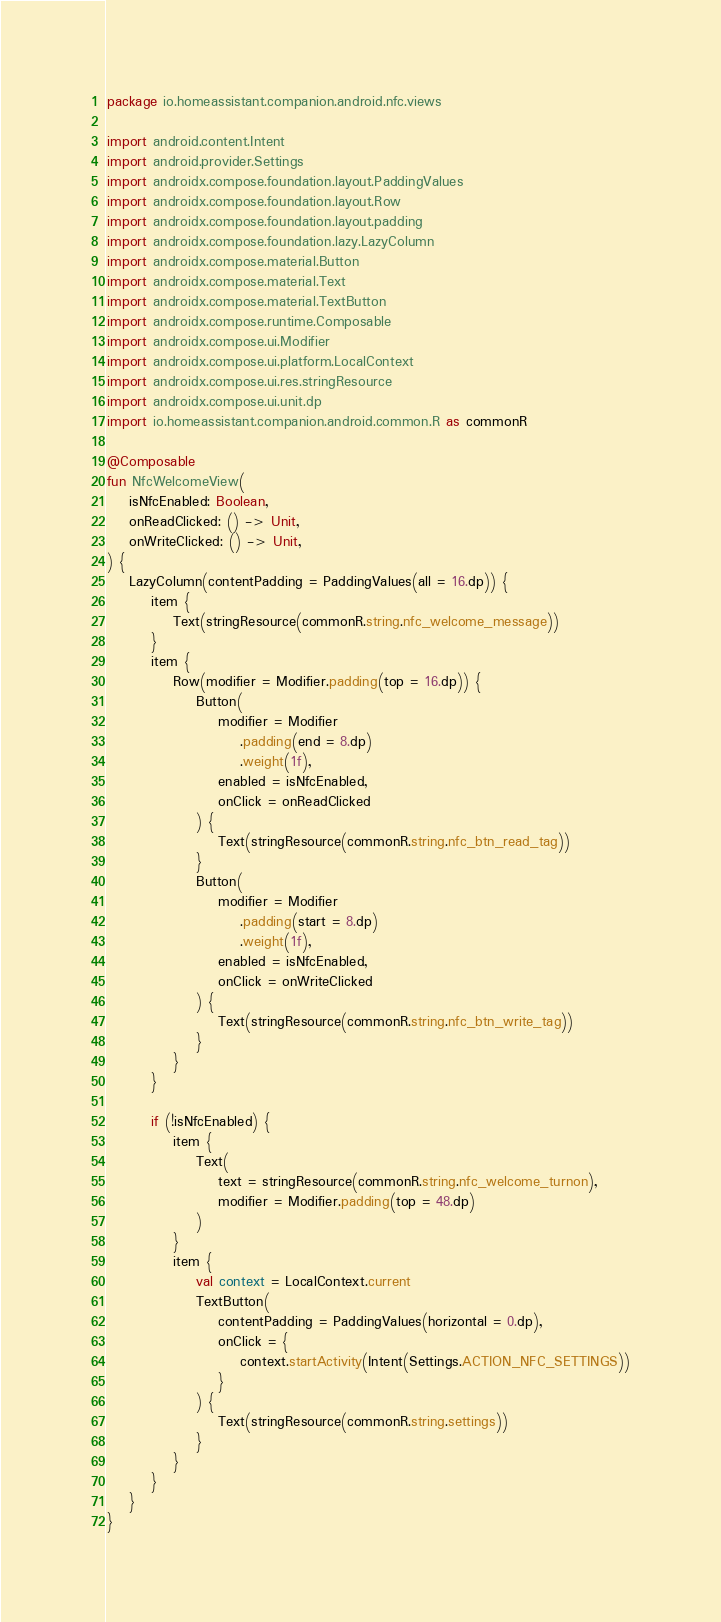Convert code to text. <code><loc_0><loc_0><loc_500><loc_500><_Kotlin_>package io.homeassistant.companion.android.nfc.views

import android.content.Intent
import android.provider.Settings
import androidx.compose.foundation.layout.PaddingValues
import androidx.compose.foundation.layout.Row
import androidx.compose.foundation.layout.padding
import androidx.compose.foundation.lazy.LazyColumn
import androidx.compose.material.Button
import androidx.compose.material.Text
import androidx.compose.material.TextButton
import androidx.compose.runtime.Composable
import androidx.compose.ui.Modifier
import androidx.compose.ui.platform.LocalContext
import androidx.compose.ui.res.stringResource
import androidx.compose.ui.unit.dp
import io.homeassistant.companion.android.common.R as commonR

@Composable
fun NfcWelcomeView(
    isNfcEnabled: Boolean,
    onReadClicked: () -> Unit,
    onWriteClicked: () -> Unit,
) {
    LazyColumn(contentPadding = PaddingValues(all = 16.dp)) {
        item {
            Text(stringResource(commonR.string.nfc_welcome_message))
        }
        item {
            Row(modifier = Modifier.padding(top = 16.dp)) {
                Button(
                    modifier = Modifier
                        .padding(end = 8.dp)
                        .weight(1f),
                    enabled = isNfcEnabled,
                    onClick = onReadClicked
                ) {
                    Text(stringResource(commonR.string.nfc_btn_read_tag))
                }
                Button(
                    modifier = Modifier
                        .padding(start = 8.dp)
                        .weight(1f),
                    enabled = isNfcEnabled,
                    onClick = onWriteClicked
                ) {
                    Text(stringResource(commonR.string.nfc_btn_write_tag))
                }
            }
        }

        if (!isNfcEnabled) {
            item {
                Text(
                    text = stringResource(commonR.string.nfc_welcome_turnon),
                    modifier = Modifier.padding(top = 48.dp)
                )
            }
            item {
                val context = LocalContext.current
                TextButton(
                    contentPadding = PaddingValues(horizontal = 0.dp),
                    onClick = {
                        context.startActivity(Intent(Settings.ACTION_NFC_SETTINGS))
                    }
                ) {
                    Text(stringResource(commonR.string.settings))
                }
            }
        }
    }
}
</code> 